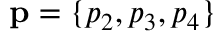<formula> <loc_0><loc_0><loc_500><loc_500>p = \{ p _ { 2 } , p _ { 3 } , p _ { 4 } \}</formula> 